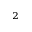Convert formula to latex. <formula><loc_0><loc_0><loc_500><loc_500>_ { 2 }</formula> 